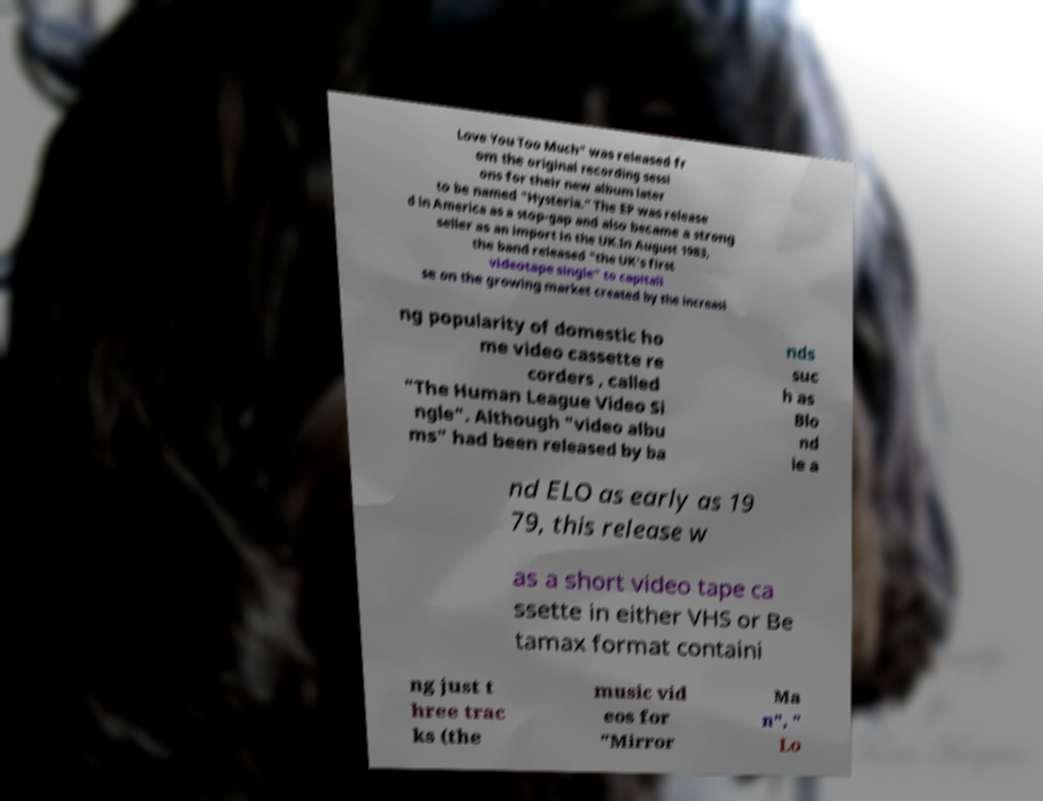Please read and relay the text visible in this image. What does it say? Love You Too Much" was released fr om the original recording sessi ons for their new album later to be named "Hysteria." The EP was release d in America as a stop-gap and also became a strong seller as an import in the UK.In August 1983, the band released "the UK's first videotape single" to capitali se on the growing market created by the increasi ng popularity of domestic ho me video cassette re corders , called "The Human League Video Si ngle". Although "video albu ms" had been released by ba nds suc h as Blo nd ie a nd ELO as early as 19 79, this release w as a short video tape ca ssette in either VHS or Be tamax format containi ng just t hree trac ks (the music vid eos for "Mirror Ma n", " Lo 